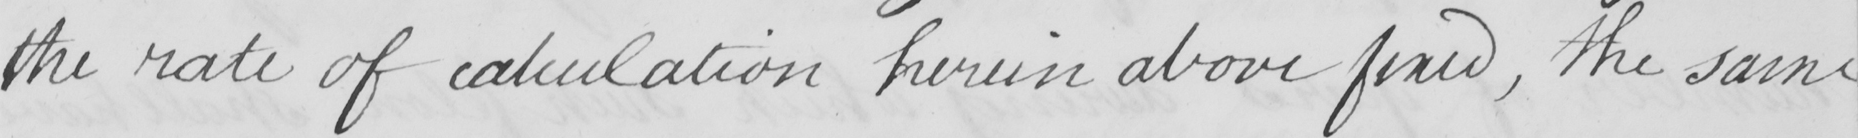Please provide the text content of this handwritten line. the rate of calculation herein and fixed , the same 